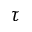Convert formula to latex. <formula><loc_0><loc_0><loc_500><loc_500>\tau</formula> 